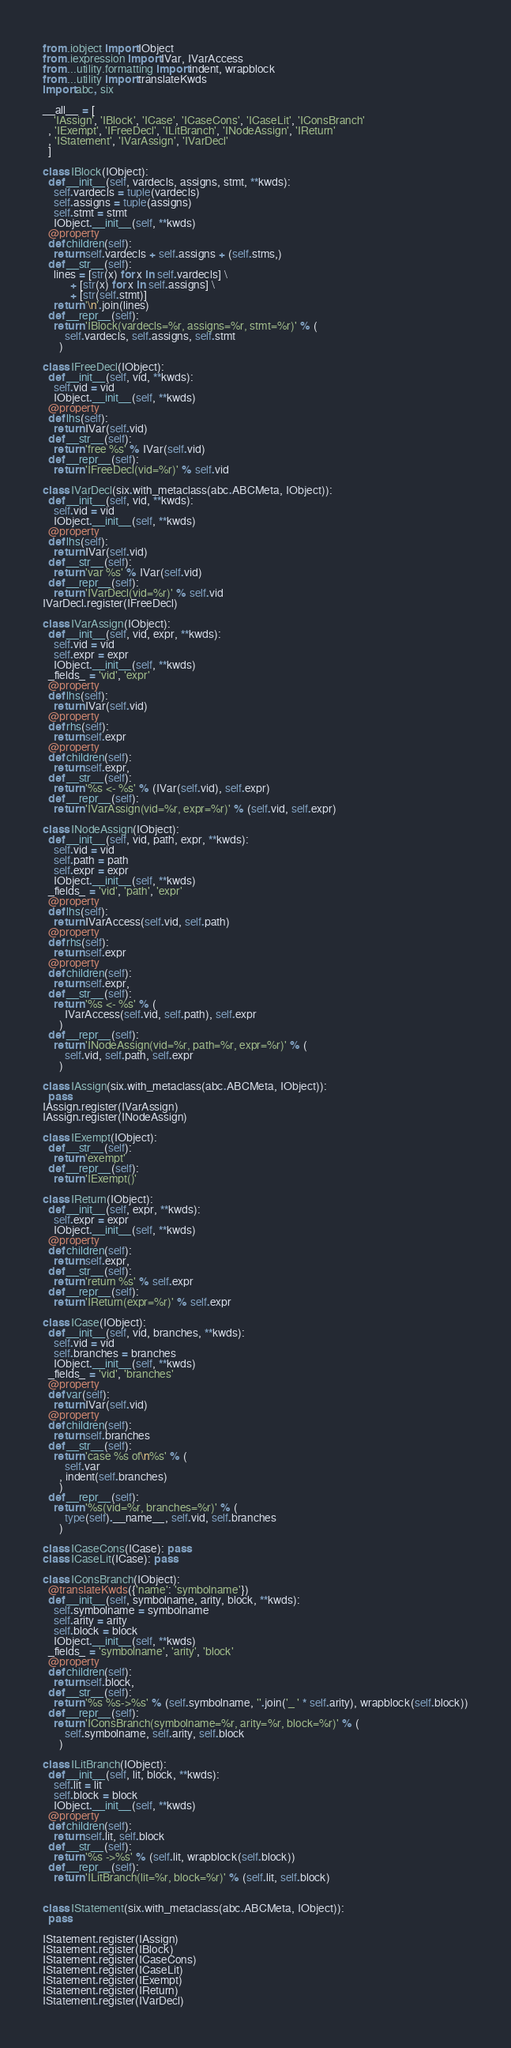Convert code to text. <code><loc_0><loc_0><loc_500><loc_500><_Python_>from .iobject import IObject
from .iexpression import IVar, IVarAccess
from ...utility.formatting import indent, wrapblock
from ...utility import translateKwds
import abc, six

__all__ = [
    'IAssign', 'IBlock', 'ICase', 'ICaseCons', 'ICaseLit', 'IConsBranch'
  , 'IExempt', 'IFreeDecl', 'ILitBranch', 'INodeAssign', 'IReturn'
  , 'IStatement', 'IVarAssign', 'IVarDecl'
  ]

class IBlock(IObject):
  def __init__(self, vardecls, assigns, stmt, **kwds):
    self.vardecls = tuple(vardecls)
    self.assigns = tuple(assigns)
    self.stmt = stmt
    IObject.__init__(self, **kwds)
  @property
  def children(self):
    return self.vardecls + self.assigns + (self.stms,)
  def __str__(self):
    lines = [str(x) for x in self.vardecls] \
          + [str(x) for x in self.assigns] \
          + [str(self.stmt)]
    return '\n'.join(lines)
  def __repr__(self):
    return 'IBlock(vardecls=%r, assigns=%r, stmt=%r)' % (
        self.vardecls, self.assigns, self.stmt
      )

class IFreeDecl(IObject):
  def __init__(self, vid, **kwds):
    self.vid = vid
    IObject.__init__(self, **kwds)
  @property
  def lhs(self):
    return IVar(self.vid)
  def __str__(self):
    return 'free %s' % IVar(self.vid)
  def __repr__(self):
    return 'IFreeDecl(vid=%r)' % self.vid

class IVarDecl(six.with_metaclass(abc.ABCMeta, IObject)):
  def __init__(self, vid, **kwds):
    self.vid = vid
    IObject.__init__(self, **kwds)
  @property
  def lhs(self):
    return IVar(self.vid)
  def __str__(self):
    return 'var %s' % IVar(self.vid)
  def __repr__(self):
    return 'IVarDecl(vid=%r)' % self.vid
IVarDecl.register(IFreeDecl)

class IVarAssign(IObject):
  def __init__(self, vid, expr, **kwds):
    self.vid = vid
    self.expr = expr
    IObject.__init__(self, **kwds)
  _fields_ = 'vid', 'expr'
  @property
  def lhs(self):
    return IVar(self.vid)
  @property
  def rhs(self):
    return self.expr
  @property
  def children(self):
    return self.expr,
  def __str__(self):
    return '%s <- %s' % (IVar(self.vid), self.expr)
  def __repr__(self):
    return 'IVarAssign(vid=%r, expr=%r)' % (self.vid, self.expr)

class INodeAssign(IObject):
  def __init__(self, vid, path, expr, **kwds):
    self.vid = vid
    self.path = path
    self.expr = expr
    IObject.__init__(self, **kwds)
  _fields_ = 'vid', 'path', 'expr'
  @property
  def lhs(self):
    return IVarAccess(self.vid, self.path)
  @property
  def rhs(self):
    return self.expr
  @property
  def children(self):
    return self.expr,
  def __str__(self):
    return '%s <- %s' % (
        IVarAccess(self.vid, self.path), self.expr
      )
  def __repr__(self):
    return 'INodeAssign(vid=%r, path=%r, expr=%r)' % (
        self.vid, self.path, self.expr
      )

class IAssign(six.with_metaclass(abc.ABCMeta, IObject)):
  pass
IAssign.register(IVarAssign)
IAssign.register(INodeAssign)

class IExempt(IObject):
  def __str__(self):
    return 'exempt'
  def __repr__(self):
    return 'IExempt()'

class IReturn(IObject):
  def __init__(self, expr, **kwds):
    self.expr = expr
    IObject.__init__(self, **kwds)
  @property
  def children(self):
    return self.expr,
  def __str__(self):
    return 'return %s' % self.expr
  def __repr__(self):
    return 'IReturn(expr=%r)' % self.expr

class ICase(IObject):
  def __init__(self, vid, branches, **kwds):
    self.vid = vid
    self.branches = branches
    IObject.__init__(self, **kwds)
  _fields_ = 'vid', 'branches'
  @property
  def var(self):
    return IVar(self.vid)
  @property
  def children(self):
    return self.branches
  def __str__(self):
    return 'case %s of\n%s' % (
        self.var
      , indent(self.branches)
      )
  def __repr__(self):
    return '%s(vid=%r, branches=%r)' % (
        type(self).__name__, self.vid, self.branches
      )

class ICaseCons(ICase): pass
class ICaseLit(ICase): pass

class IConsBranch(IObject):
  @translateKwds({'name': 'symbolname'})
  def __init__(self, symbolname, arity, block, **kwds):
    self.symbolname = symbolname
    self.arity = arity
    self.block = block
    IObject.__init__(self, **kwds)
  _fields_ = 'symbolname', 'arity', 'block'
  @property
  def children(self):
    return self.block,
  def __str__(self):
    return '%s %s->%s' % (self.symbolname, ''.join('_ ' * self.arity), wrapblock(self.block))
  def __repr__(self):
    return 'IConsBranch(symbolname=%r, arity=%r, block=%r)' % (
        self.symbolname, self.arity, self.block
      )

class ILitBranch(IObject):
  def __init__(self, lit, block, **kwds):
    self.lit = lit
    self.block = block
    IObject.__init__(self, **kwds)
  @property
  def children(self):
    return self.lit, self.block
  def __str__(self):
    return '%s ->%s' % (self.lit, wrapblock(self.block))
  def __repr__(self):
    return 'ILitBranch(lit=%r, block=%r)' % (self.lit, self.block)


class IStatement(six.with_metaclass(abc.ABCMeta, IObject)):
  pass

IStatement.register(IAssign)
IStatement.register(IBlock)
IStatement.register(ICaseCons)
IStatement.register(ICaseLit)
IStatement.register(IExempt)
IStatement.register(IReturn)
IStatement.register(IVarDecl)
</code> 